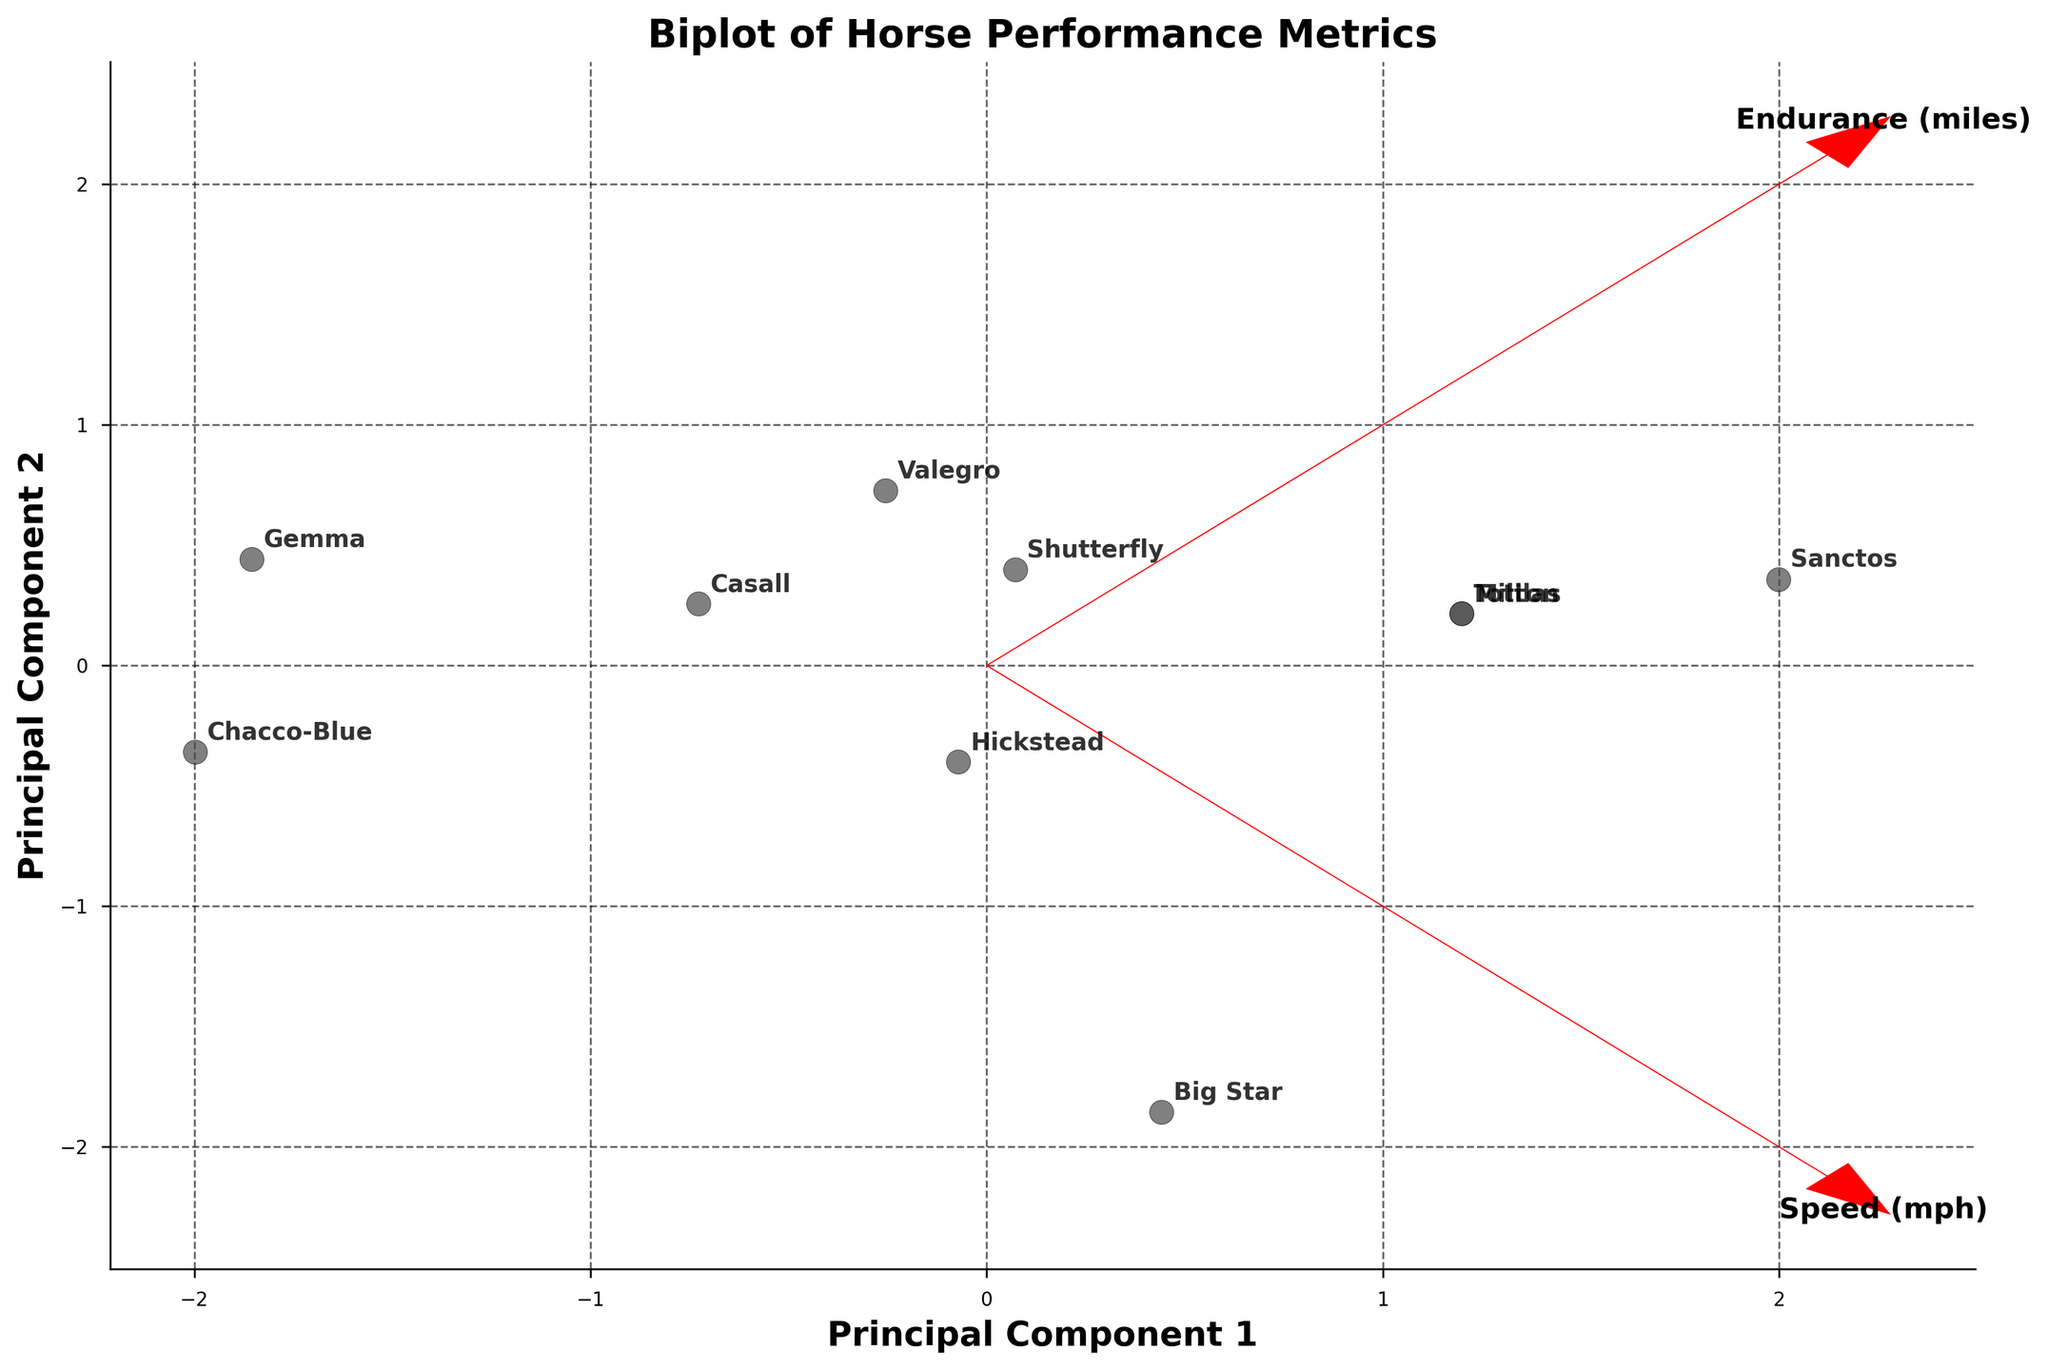What's the title of the plot? Look at the top of the plot where the title is located. It is typically the largest text and gives an overview of what the figure represents.
Answer: Biplot of Horse Performance Metrics How many horses are shown in the plot? Count each unique point labeled with a horse's name on the plot.
Answer: 10 Which horse has the highest Speed (mph)? Locate the direction of the Speed (mph) vector and identify the point that is furthest along that direction.
Answer: Sanctos How many axes are used in the plot and what are they labeled? Identify the horizontal and vertical lines that intersect at the origin and check the text labels next to them.
Answer: Two axes; Principal Component 1 and Principal Component 2 Which horse has a combination of high Speed and high Endurance? Look for points that are far along both the Speed (mph) and Endurance (miles) vectors.
Answer: Casall Which horse appears closest to the origin in the plot? Find the point that is nearest to the center where the two axes cross.
Answer: Big Star Which horse is most associated with good Endurance (miles) but lower Speed (mph)? Identify the vector related to Endurance (miles) and look for the point that is farthest along this vector but not as far on the Speed (mph) vector.
Answer: Gemma What principal component does the vector for Speed (mph) mostly align with? Observe the direction of the Speed (mph) vector and determine which principal component axis it is most parallel to.
Answer: Principal Component 1 Based on the plot, which horse would be considered average in the performance metrics of Speed and Endurance? Look for points that are close to the origin, indicating mean values after standardization.
Answer: Big Star Are there any horses that align closely with both high Speed and high Agility? Find the direction vectors for Speed (mph) and Agility, then locate points aligned closely with both vectors.
Answer: Casall and Valegro 